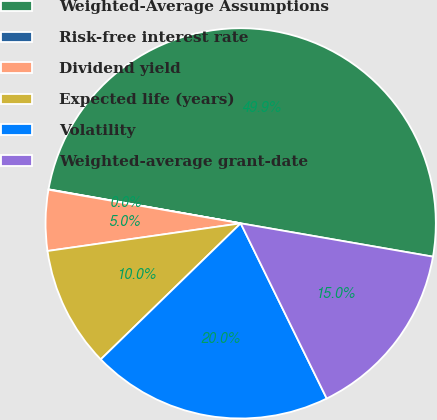Convert chart. <chart><loc_0><loc_0><loc_500><loc_500><pie_chart><fcel>Weighted-Average Assumptions<fcel>Risk-free interest rate<fcel>Dividend yield<fcel>Expected life (years)<fcel>Volatility<fcel>Weighted-average grant-date<nl><fcel>49.94%<fcel>0.03%<fcel>5.02%<fcel>10.01%<fcel>19.99%<fcel>15.0%<nl></chart> 